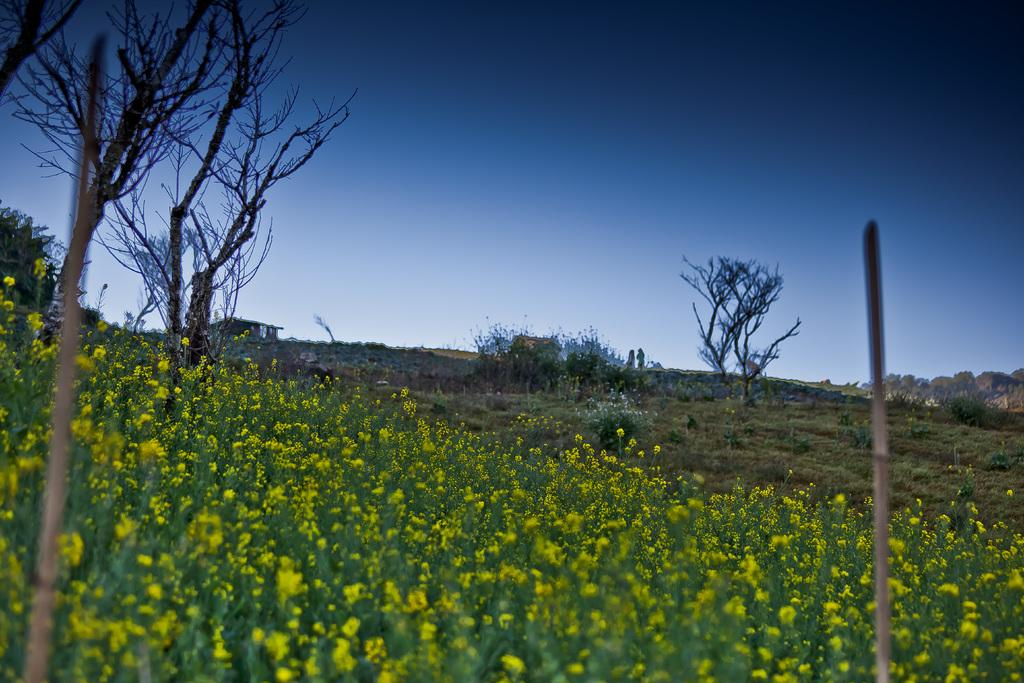What type of flowers can be seen on the left side of the image? There are yellow flowers on the left side of the image. What type of vegetation is visible in the image? There is grass visible in the image. What can be seen in the background of the image? There are trees and the sky visible in the background of the image. Is there a train passing by in the image? No, there is no train present in the image. Can you see a hat on any of the trees in the image? No, there are no hats visible on the trees or anywhere else in the image. 